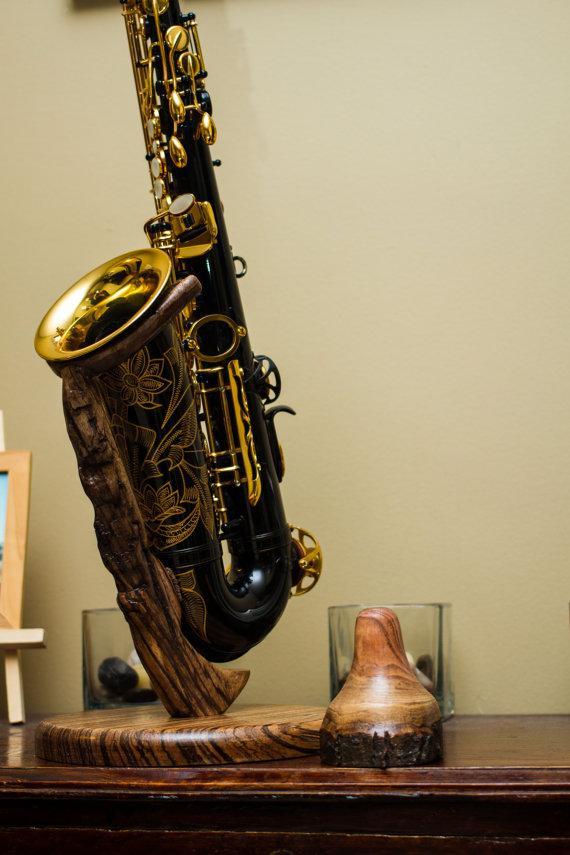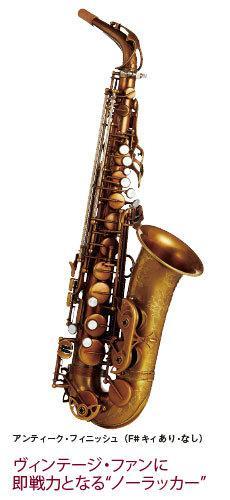The first image is the image on the left, the second image is the image on the right. Assess this claim about the two images: "The saxophone in the image on the left is on a stand.". Correct or not? Answer yes or no. Yes. 